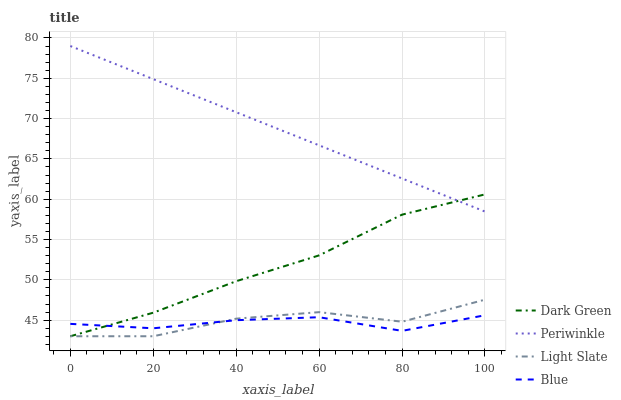Does Blue have the minimum area under the curve?
Answer yes or no. Yes. Does Periwinkle have the maximum area under the curve?
Answer yes or no. Yes. Does Periwinkle have the minimum area under the curve?
Answer yes or no. No. Does Blue have the maximum area under the curve?
Answer yes or no. No. Is Periwinkle the smoothest?
Answer yes or no. Yes. Is Light Slate the roughest?
Answer yes or no. Yes. Is Blue the smoothest?
Answer yes or no. No. Is Blue the roughest?
Answer yes or no. No. Does Light Slate have the lowest value?
Answer yes or no. Yes. Does Blue have the lowest value?
Answer yes or no. No. Does Periwinkle have the highest value?
Answer yes or no. Yes. Does Blue have the highest value?
Answer yes or no. No. Is Light Slate less than Periwinkle?
Answer yes or no. Yes. Is Periwinkle greater than Blue?
Answer yes or no. Yes. Does Periwinkle intersect Dark Green?
Answer yes or no. Yes. Is Periwinkle less than Dark Green?
Answer yes or no. No. Is Periwinkle greater than Dark Green?
Answer yes or no. No. Does Light Slate intersect Periwinkle?
Answer yes or no. No. 